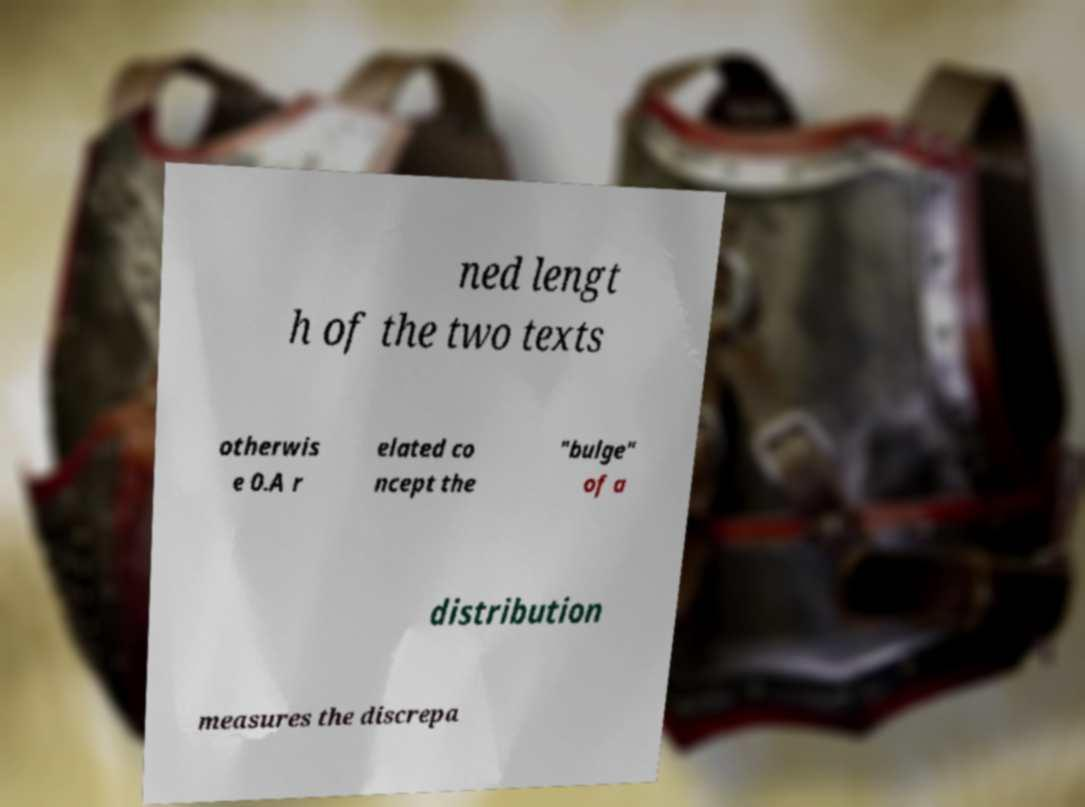Please read and relay the text visible in this image. What does it say? ned lengt h of the two texts otherwis e 0.A r elated co ncept the "bulge" of a distribution measures the discrepa 